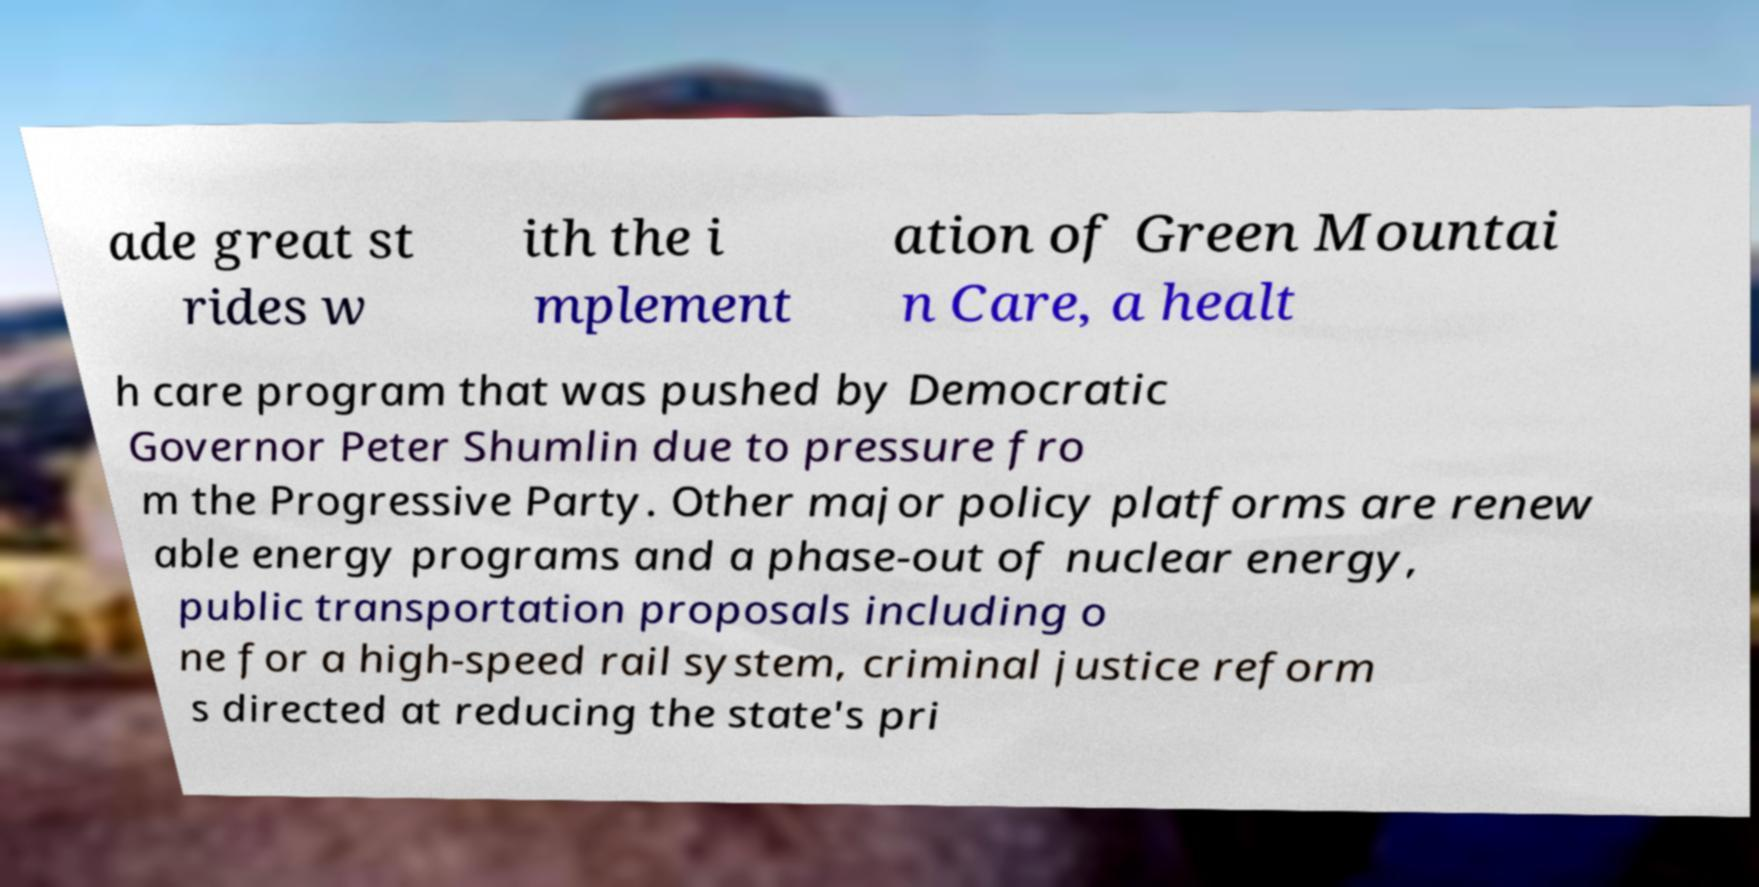For documentation purposes, I need the text within this image transcribed. Could you provide that? ade great st rides w ith the i mplement ation of Green Mountai n Care, a healt h care program that was pushed by Democratic Governor Peter Shumlin due to pressure fro m the Progressive Party. Other major policy platforms are renew able energy programs and a phase-out of nuclear energy, public transportation proposals including o ne for a high-speed rail system, criminal justice reform s directed at reducing the state's pri 